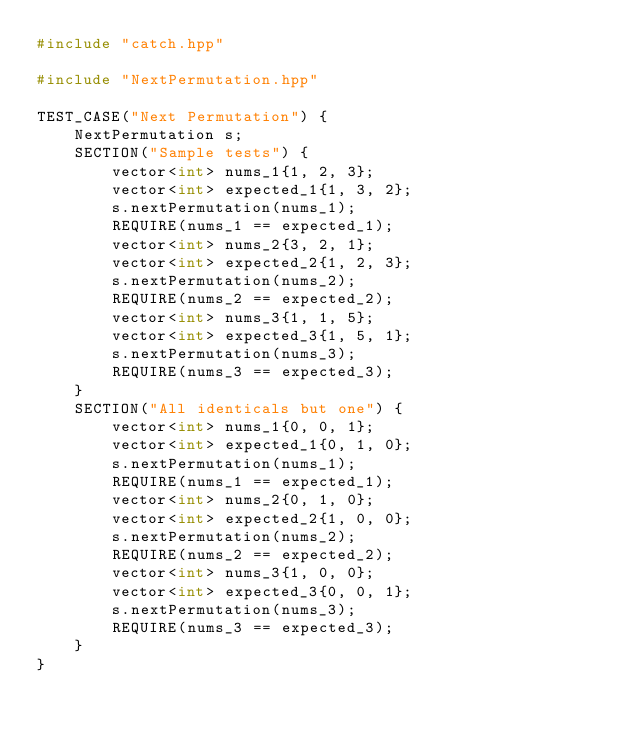<code> <loc_0><loc_0><loc_500><loc_500><_C++_>#include "catch.hpp"

#include "NextPermutation.hpp"

TEST_CASE("Next Permutation") {
    NextPermutation s;
    SECTION("Sample tests") {
        vector<int> nums_1{1, 2, 3};
        vector<int> expected_1{1, 3, 2};
        s.nextPermutation(nums_1);
        REQUIRE(nums_1 == expected_1);
        vector<int> nums_2{3, 2, 1};
        vector<int> expected_2{1, 2, 3};
        s.nextPermutation(nums_2);
        REQUIRE(nums_2 == expected_2);
        vector<int> nums_3{1, 1, 5};
        vector<int> expected_3{1, 5, 1};
        s.nextPermutation(nums_3);
        REQUIRE(nums_3 == expected_3);
    }
    SECTION("All identicals but one") {
        vector<int> nums_1{0, 0, 1};
        vector<int> expected_1{0, 1, 0};
        s.nextPermutation(nums_1);
        REQUIRE(nums_1 == expected_1);
        vector<int> nums_2{0, 1, 0};
        vector<int> expected_2{1, 0, 0};
        s.nextPermutation(nums_2);
        REQUIRE(nums_2 == expected_2);
        vector<int> nums_3{1, 0, 0};
        vector<int> expected_3{0, 0, 1};
        s.nextPermutation(nums_3);
        REQUIRE(nums_3 == expected_3);
    }
}
</code> 